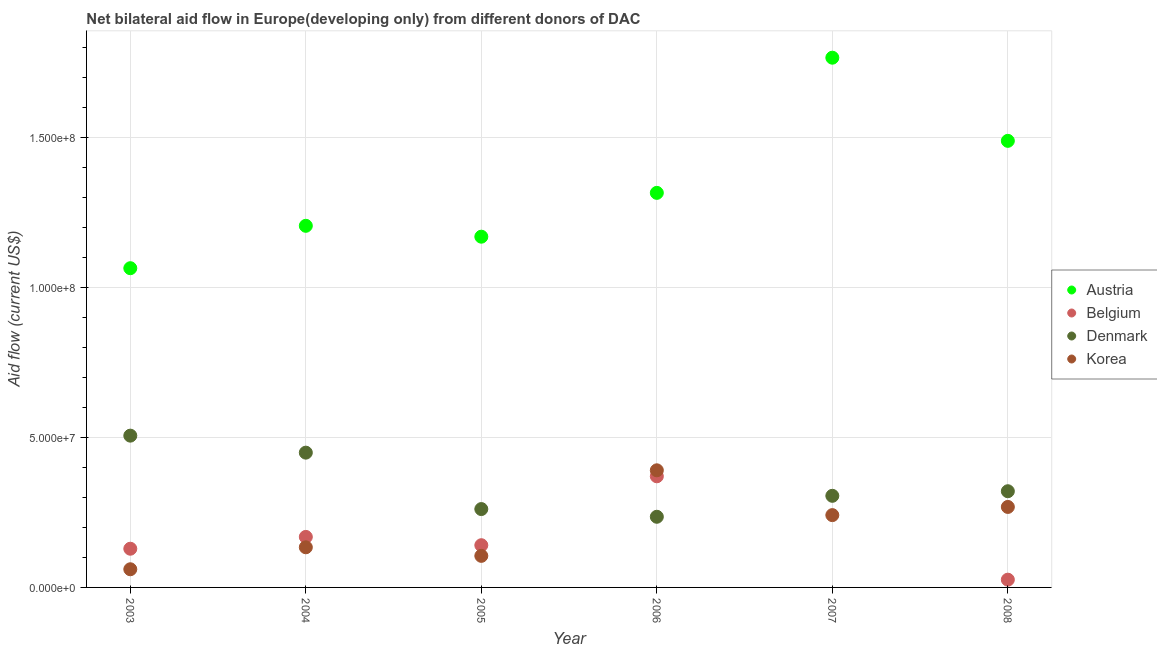How many different coloured dotlines are there?
Your response must be concise. 4. What is the amount of aid given by austria in 2006?
Your response must be concise. 1.32e+08. Across all years, what is the maximum amount of aid given by korea?
Offer a very short reply. 3.91e+07. Across all years, what is the minimum amount of aid given by belgium?
Your response must be concise. 0. In which year was the amount of aid given by korea maximum?
Ensure brevity in your answer.  2006. What is the total amount of aid given by denmark in the graph?
Keep it short and to the point. 2.08e+08. What is the difference between the amount of aid given by austria in 2005 and that in 2008?
Your answer should be compact. -3.20e+07. What is the difference between the amount of aid given by korea in 2003 and the amount of aid given by austria in 2004?
Offer a terse response. -1.15e+08. What is the average amount of aid given by denmark per year?
Ensure brevity in your answer.  3.47e+07. In the year 2003, what is the difference between the amount of aid given by austria and amount of aid given by belgium?
Offer a terse response. 9.36e+07. In how many years, is the amount of aid given by austria greater than 30000000 US$?
Provide a short and direct response. 6. What is the ratio of the amount of aid given by korea in 2003 to that in 2008?
Keep it short and to the point. 0.23. What is the difference between the highest and the second highest amount of aid given by austria?
Your answer should be very brief. 2.77e+07. What is the difference between the highest and the lowest amount of aid given by belgium?
Offer a terse response. 3.71e+07. In how many years, is the amount of aid given by belgium greater than the average amount of aid given by belgium taken over all years?
Your answer should be compact. 3. Is it the case that in every year, the sum of the amount of aid given by austria and amount of aid given by denmark is greater than the sum of amount of aid given by korea and amount of aid given by belgium?
Make the answer very short. Yes. Is the amount of aid given by korea strictly less than the amount of aid given by belgium over the years?
Keep it short and to the point. No. What is the difference between two consecutive major ticks on the Y-axis?
Provide a succinct answer. 5.00e+07. Are the values on the major ticks of Y-axis written in scientific E-notation?
Offer a very short reply. Yes. Does the graph contain any zero values?
Give a very brief answer. Yes. What is the title of the graph?
Provide a short and direct response. Net bilateral aid flow in Europe(developing only) from different donors of DAC. Does "Italy" appear as one of the legend labels in the graph?
Provide a short and direct response. No. What is the label or title of the X-axis?
Offer a terse response. Year. What is the label or title of the Y-axis?
Your answer should be compact. Aid flow (current US$). What is the Aid flow (current US$) of Austria in 2003?
Keep it short and to the point. 1.06e+08. What is the Aid flow (current US$) in Belgium in 2003?
Your answer should be compact. 1.29e+07. What is the Aid flow (current US$) of Denmark in 2003?
Ensure brevity in your answer.  5.06e+07. What is the Aid flow (current US$) of Korea in 2003?
Offer a very short reply. 6.06e+06. What is the Aid flow (current US$) of Austria in 2004?
Provide a succinct answer. 1.21e+08. What is the Aid flow (current US$) in Belgium in 2004?
Offer a very short reply. 1.68e+07. What is the Aid flow (current US$) of Denmark in 2004?
Your response must be concise. 4.50e+07. What is the Aid flow (current US$) in Korea in 2004?
Your answer should be compact. 1.34e+07. What is the Aid flow (current US$) in Austria in 2005?
Make the answer very short. 1.17e+08. What is the Aid flow (current US$) in Belgium in 2005?
Offer a very short reply. 1.41e+07. What is the Aid flow (current US$) in Denmark in 2005?
Offer a terse response. 2.61e+07. What is the Aid flow (current US$) in Korea in 2005?
Give a very brief answer. 1.05e+07. What is the Aid flow (current US$) in Austria in 2006?
Give a very brief answer. 1.32e+08. What is the Aid flow (current US$) in Belgium in 2006?
Provide a succinct answer. 3.71e+07. What is the Aid flow (current US$) in Denmark in 2006?
Provide a succinct answer. 2.36e+07. What is the Aid flow (current US$) of Korea in 2006?
Your response must be concise. 3.91e+07. What is the Aid flow (current US$) of Austria in 2007?
Provide a short and direct response. 1.77e+08. What is the Aid flow (current US$) in Belgium in 2007?
Keep it short and to the point. 0. What is the Aid flow (current US$) in Denmark in 2007?
Provide a succinct answer. 3.06e+07. What is the Aid flow (current US$) of Korea in 2007?
Offer a terse response. 2.41e+07. What is the Aid flow (current US$) of Austria in 2008?
Give a very brief answer. 1.49e+08. What is the Aid flow (current US$) in Belgium in 2008?
Your response must be concise. 2.59e+06. What is the Aid flow (current US$) in Denmark in 2008?
Offer a terse response. 3.21e+07. What is the Aid flow (current US$) in Korea in 2008?
Keep it short and to the point. 2.68e+07. Across all years, what is the maximum Aid flow (current US$) of Austria?
Make the answer very short. 1.77e+08. Across all years, what is the maximum Aid flow (current US$) in Belgium?
Make the answer very short. 3.71e+07. Across all years, what is the maximum Aid flow (current US$) of Denmark?
Your response must be concise. 5.06e+07. Across all years, what is the maximum Aid flow (current US$) in Korea?
Provide a succinct answer. 3.91e+07. Across all years, what is the minimum Aid flow (current US$) in Austria?
Your answer should be compact. 1.06e+08. Across all years, what is the minimum Aid flow (current US$) in Belgium?
Ensure brevity in your answer.  0. Across all years, what is the minimum Aid flow (current US$) in Denmark?
Offer a terse response. 2.36e+07. Across all years, what is the minimum Aid flow (current US$) in Korea?
Your response must be concise. 6.06e+06. What is the total Aid flow (current US$) of Austria in the graph?
Keep it short and to the point. 8.01e+08. What is the total Aid flow (current US$) in Belgium in the graph?
Keep it short and to the point. 8.35e+07. What is the total Aid flow (current US$) in Denmark in the graph?
Make the answer very short. 2.08e+08. What is the total Aid flow (current US$) of Korea in the graph?
Your response must be concise. 1.20e+08. What is the difference between the Aid flow (current US$) of Austria in 2003 and that in 2004?
Offer a very short reply. -1.41e+07. What is the difference between the Aid flow (current US$) of Belgium in 2003 and that in 2004?
Ensure brevity in your answer.  -3.94e+06. What is the difference between the Aid flow (current US$) of Denmark in 2003 and that in 2004?
Your answer should be very brief. 5.67e+06. What is the difference between the Aid flow (current US$) in Korea in 2003 and that in 2004?
Your answer should be compact. -7.33e+06. What is the difference between the Aid flow (current US$) in Austria in 2003 and that in 2005?
Offer a terse response. -1.05e+07. What is the difference between the Aid flow (current US$) of Belgium in 2003 and that in 2005?
Offer a very short reply. -1.17e+06. What is the difference between the Aid flow (current US$) of Denmark in 2003 and that in 2005?
Offer a terse response. 2.45e+07. What is the difference between the Aid flow (current US$) in Korea in 2003 and that in 2005?
Ensure brevity in your answer.  -4.47e+06. What is the difference between the Aid flow (current US$) in Austria in 2003 and that in 2006?
Provide a short and direct response. -2.51e+07. What is the difference between the Aid flow (current US$) in Belgium in 2003 and that in 2006?
Ensure brevity in your answer.  -2.42e+07. What is the difference between the Aid flow (current US$) in Denmark in 2003 and that in 2006?
Ensure brevity in your answer.  2.71e+07. What is the difference between the Aid flow (current US$) of Korea in 2003 and that in 2006?
Offer a very short reply. -3.30e+07. What is the difference between the Aid flow (current US$) in Austria in 2003 and that in 2007?
Keep it short and to the point. -7.02e+07. What is the difference between the Aid flow (current US$) of Denmark in 2003 and that in 2007?
Ensure brevity in your answer.  2.01e+07. What is the difference between the Aid flow (current US$) in Korea in 2003 and that in 2007?
Your answer should be compact. -1.81e+07. What is the difference between the Aid flow (current US$) of Austria in 2003 and that in 2008?
Offer a very short reply. -4.25e+07. What is the difference between the Aid flow (current US$) in Belgium in 2003 and that in 2008?
Provide a short and direct response. 1.03e+07. What is the difference between the Aid flow (current US$) in Denmark in 2003 and that in 2008?
Keep it short and to the point. 1.85e+07. What is the difference between the Aid flow (current US$) of Korea in 2003 and that in 2008?
Provide a short and direct response. -2.08e+07. What is the difference between the Aid flow (current US$) in Austria in 2004 and that in 2005?
Ensure brevity in your answer.  3.63e+06. What is the difference between the Aid flow (current US$) of Belgium in 2004 and that in 2005?
Provide a short and direct response. 2.77e+06. What is the difference between the Aid flow (current US$) in Denmark in 2004 and that in 2005?
Give a very brief answer. 1.88e+07. What is the difference between the Aid flow (current US$) of Korea in 2004 and that in 2005?
Provide a short and direct response. 2.86e+06. What is the difference between the Aid flow (current US$) of Austria in 2004 and that in 2006?
Keep it short and to the point. -1.10e+07. What is the difference between the Aid flow (current US$) in Belgium in 2004 and that in 2006?
Your answer should be compact. -2.02e+07. What is the difference between the Aid flow (current US$) in Denmark in 2004 and that in 2006?
Ensure brevity in your answer.  2.14e+07. What is the difference between the Aid flow (current US$) of Korea in 2004 and that in 2006?
Offer a very short reply. -2.57e+07. What is the difference between the Aid flow (current US$) of Austria in 2004 and that in 2007?
Keep it short and to the point. -5.61e+07. What is the difference between the Aid flow (current US$) in Denmark in 2004 and that in 2007?
Keep it short and to the point. 1.44e+07. What is the difference between the Aid flow (current US$) in Korea in 2004 and that in 2007?
Provide a succinct answer. -1.07e+07. What is the difference between the Aid flow (current US$) of Austria in 2004 and that in 2008?
Provide a short and direct response. -2.83e+07. What is the difference between the Aid flow (current US$) of Belgium in 2004 and that in 2008?
Your response must be concise. 1.43e+07. What is the difference between the Aid flow (current US$) of Denmark in 2004 and that in 2008?
Your answer should be compact. 1.29e+07. What is the difference between the Aid flow (current US$) of Korea in 2004 and that in 2008?
Ensure brevity in your answer.  -1.35e+07. What is the difference between the Aid flow (current US$) in Austria in 2005 and that in 2006?
Your answer should be very brief. -1.46e+07. What is the difference between the Aid flow (current US$) of Belgium in 2005 and that in 2006?
Your answer should be very brief. -2.30e+07. What is the difference between the Aid flow (current US$) in Denmark in 2005 and that in 2006?
Give a very brief answer. 2.57e+06. What is the difference between the Aid flow (current US$) in Korea in 2005 and that in 2006?
Offer a terse response. -2.85e+07. What is the difference between the Aid flow (current US$) in Austria in 2005 and that in 2007?
Give a very brief answer. -5.97e+07. What is the difference between the Aid flow (current US$) of Denmark in 2005 and that in 2007?
Your response must be concise. -4.42e+06. What is the difference between the Aid flow (current US$) of Korea in 2005 and that in 2007?
Ensure brevity in your answer.  -1.36e+07. What is the difference between the Aid flow (current US$) of Austria in 2005 and that in 2008?
Your answer should be very brief. -3.20e+07. What is the difference between the Aid flow (current US$) in Belgium in 2005 and that in 2008?
Your response must be concise. 1.15e+07. What is the difference between the Aid flow (current US$) of Denmark in 2005 and that in 2008?
Provide a succinct answer. -5.95e+06. What is the difference between the Aid flow (current US$) of Korea in 2005 and that in 2008?
Offer a very short reply. -1.63e+07. What is the difference between the Aid flow (current US$) in Austria in 2006 and that in 2007?
Your answer should be very brief. -4.51e+07. What is the difference between the Aid flow (current US$) in Denmark in 2006 and that in 2007?
Your answer should be very brief. -6.99e+06. What is the difference between the Aid flow (current US$) of Korea in 2006 and that in 2007?
Provide a short and direct response. 1.50e+07. What is the difference between the Aid flow (current US$) in Austria in 2006 and that in 2008?
Offer a very short reply. -1.74e+07. What is the difference between the Aid flow (current US$) of Belgium in 2006 and that in 2008?
Offer a terse response. 3.45e+07. What is the difference between the Aid flow (current US$) in Denmark in 2006 and that in 2008?
Provide a succinct answer. -8.52e+06. What is the difference between the Aid flow (current US$) of Korea in 2006 and that in 2008?
Offer a very short reply. 1.22e+07. What is the difference between the Aid flow (current US$) in Austria in 2007 and that in 2008?
Provide a short and direct response. 2.77e+07. What is the difference between the Aid flow (current US$) of Denmark in 2007 and that in 2008?
Make the answer very short. -1.53e+06. What is the difference between the Aid flow (current US$) of Korea in 2007 and that in 2008?
Offer a terse response. -2.73e+06. What is the difference between the Aid flow (current US$) in Austria in 2003 and the Aid flow (current US$) in Belgium in 2004?
Provide a short and direct response. 8.96e+07. What is the difference between the Aid flow (current US$) of Austria in 2003 and the Aid flow (current US$) of Denmark in 2004?
Offer a very short reply. 6.15e+07. What is the difference between the Aid flow (current US$) in Austria in 2003 and the Aid flow (current US$) in Korea in 2004?
Provide a succinct answer. 9.31e+07. What is the difference between the Aid flow (current US$) of Belgium in 2003 and the Aid flow (current US$) of Denmark in 2004?
Offer a very short reply. -3.20e+07. What is the difference between the Aid flow (current US$) in Belgium in 2003 and the Aid flow (current US$) in Korea in 2004?
Your response must be concise. -4.80e+05. What is the difference between the Aid flow (current US$) of Denmark in 2003 and the Aid flow (current US$) of Korea in 2004?
Keep it short and to the point. 3.72e+07. What is the difference between the Aid flow (current US$) of Austria in 2003 and the Aid flow (current US$) of Belgium in 2005?
Offer a terse response. 9.24e+07. What is the difference between the Aid flow (current US$) in Austria in 2003 and the Aid flow (current US$) in Denmark in 2005?
Provide a short and direct response. 8.04e+07. What is the difference between the Aid flow (current US$) in Austria in 2003 and the Aid flow (current US$) in Korea in 2005?
Provide a succinct answer. 9.60e+07. What is the difference between the Aid flow (current US$) of Belgium in 2003 and the Aid flow (current US$) of Denmark in 2005?
Offer a very short reply. -1.32e+07. What is the difference between the Aid flow (current US$) of Belgium in 2003 and the Aid flow (current US$) of Korea in 2005?
Your response must be concise. 2.38e+06. What is the difference between the Aid flow (current US$) in Denmark in 2003 and the Aid flow (current US$) in Korea in 2005?
Ensure brevity in your answer.  4.01e+07. What is the difference between the Aid flow (current US$) of Austria in 2003 and the Aid flow (current US$) of Belgium in 2006?
Offer a terse response. 6.94e+07. What is the difference between the Aid flow (current US$) in Austria in 2003 and the Aid flow (current US$) in Denmark in 2006?
Your answer should be compact. 8.29e+07. What is the difference between the Aid flow (current US$) in Austria in 2003 and the Aid flow (current US$) in Korea in 2006?
Give a very brief answer. 6.74e+07. What is the difference between the Aid flow (current US$) of Belgium in 2003 and the Aid flow (current US$) of Denmark in 2006?
Offer a very short reply. -1.07e+07. What is the difference between the Aid flow (current US$) of Belgium in 2003 and the Aid flow (current US$) of Korea in 2006?
Your response must be concise. -2.62e+07. What is the difference between the Aid flow (current US$) in Denmark in 2003 and the Aid flow (current US$) in Korea in 2006?
Provide a short and direct response. 1.16e+07. What is the difference between the Aid flow (current US$) of Austria in 2003 and the Aid flow (current US$) of Denmark in 2007?
Your answer should be compact. 7.59e+07. What is the difference between the Aid flow (current US$) of Austria in 2003 and the Aid flow (current US$) of Korea in 2007?
Give a very brief answer. 8.24e+07. What is the difference between the Aid flow (current US$) in Belgium in 2003 and the Aid flow (current US$) in Denmark in 2007?
Offer a terse response. -1.76e+07. What is the difference between the Aid flow (current US$) in Belgium in 2003 and the Aid flow (current US$) in Korea in 2007?
Provide a short and direct response. -1.12e+07. What is the difference between the Aid flow (current US$) in Denmark in 2003 and the Aid flow (current US$) in Korea in 2007?
Keep it short and to the point. 2.65e+07. What is the difference between the Aid flow (current US$) in Austria in 2003 and the Aid flow (current US$) in Belgium in 2008?
Give a very brief answer. 1.04e+08. What is the difference between the Aid flow (current US$) in Austria in 2003 and the Aid flow (current US$) in Denmark in 2008?
Offer a very short reply. 7.44e+07. What is the difference between the Aid flow (current US$) in Austria in 2003 and the Aid flow (current US$) in Korea in 2008?
Offer a very short reply. 7.96e+07. What is the difference between the Aid flow (current US$) in Belgium in 2003 and the Aid flow (current US$) in Denmark in 2008?
Your answer should be very brief. -1.92e+07. What is the difference between the Aid flow (current US$) in Belgium in 2003 and the Aid flow (current US$) in Korea in 2008?
Provide a succinct answer. -1.39e+07. What is the difference between the Aid flow (current US$) in Denmark in 2003 and the Aid flow (current US$) in Korea in 2008?
Make the answer very short. 2.38e+07. What is the difference between the Aid flow (current US$) of Austria in 2004 and the Aid flow (current US$) of Belgium in 2005?
Your answer should be very brief. 1.07e+08. What is the difference between the Aid flow (current US$) in Austria in 2004 and the Aid flow (current US$) in Denmark in 2005?
Your answer should be very brief. 9.45e+07. What is the difference between the Aid flow (current US$) of Austria in 2004 and the Aid flow (current US$) of Korea in 2005?
Keep it short and to the point. 1.10e+08. What is the difference between the Aid flow (current US$) in Belgium in 2004 and the Aid flow (current US$) in Denmark in 2005?
Offer a terse response. -9.29e+06. What is the difference between the Aid flow (current US$) of Belgium in 2004 and the Aid flow (current US$) of Korea in 2005?
Make the answer very short. 6.32e+06. What is the difference between the Aid flow (current US$) of Denmark in 2004 and the Aid flow (current US$) of Korea in 2005?
Your answer should be compact. 3.44e+07. What is the difference between the Aid flow (current US$) of Austria in 2004 and the Aid flow (current US$) of Belgium in 2006?
Provide a succinct answer. 8.36e+07. What is the difference between the Aid flow (current US$) of Austria in 2004 and the Aid flow (current US$) of Denmark in 2006?
Keep it short and to the point. 9.71e+07. What is the difference between the Aid flow (current US$) in Austria in 2004 and the Aid flow (current US$) in Korea in 2006?
Ensure brevity in your answer.  8.16e+07. What is the difference between the Aid flow (current US$) in Belgium in 2004 and the Aid flow (current US$) in Denmark in 2006?
Give a very brief answer. -6.72e+06. What is the difference between the Aid flow (current US$) of Belgium in 2004 and the Aid flow (current US$) of Korea in 2006?
Your answer should be compact. -2.22e+07. What is the difference between the Aid flow (current US$) in Denmark in 2004 and the Aid flow (current US$) in Korea in 2006?
Give a very brief answer. 5.89e+06. What is the difference between the Aid flow (current US$) in Austria in 2004 and the Aid flow (current US$) in Denmark in 2007?
Offer a very short reply. 9.01e+07. What is the difference between the Aid flow (current US$) of Austria in 2004 and the Aid flow (current US$) of Korea in 2007?
Offer a very short reply. 9.65e+07. What is the difference between the Aid flow (current US$) in Belgium in 2004 and the Aid flow (current US$) in Denmark in 2007?
Your answer should be very brief. -1.37e+07. What is the difference between the Aid flow (current US$) in Belgium in 2004 and the Aid flow (current US$) in Korea in 2007?
Offer a terse response. -7.27e+06. What is the difference between the Aid flow (current US$) of Denmark in 2004 and the Aid flow (current US$) of Korea in 2007?
Your answer should be very brief. 2.08e+07. What is the difference between the Aid flow (current US$) in Austria in 2004 and the Aid flow (current US$) in Belgium in 2008?
Your answer should be compact. 1.18e+08. What is the difference between the Aid flow (current US$) of Austria in 2004 and the Aid flow (current US$) of Denmark in 2008?
Your answer should be compact. 8.85e+07. What is the difference between the Aid flow (current US$) of Austria in 2004 and the Aid flow (current US$) of Korea in 2008?
Make the answer very short. 9.38e+07. What is the difference between the Aid flow (current US$) of Belgium in 2004 and the Aid flow (current US$) of Denmark in 2008?
Give a very brief answer. -1.52e+07. What is the difference between the Aid flow (current US$) of Belgium in 2004 and the Aid flow (current US$) of Korea in 2008?
Offer a very short reply. -1.00e+07. What is the difference between the Aid flow (current US$) in Denmark in 2004 and the Aid flow (current US$) in Korea in 2008?
Make the answer very short. 1.81e+07. What is the difference between the Aid flow (current US$) in Austria in 2005 and the Aid flow (current US$) in Belgium in 2006?
Your response must be concise. 7.99e+07. What is the difference between the Aid flow (current US$) of Austria in 2005 and the Aid flow (current US$) of Denmark in 2006?
Your answer should be compact. 9.34e+07. What is the difference between the Aid flow (current US$) in Austria in 2005 and the Aid flow (current US$) in Korea in 2006?
Give a very brief answer. 7.79e+07. What is the difference between the Aid flow (current US$) in Belgium in 2005 and the Aid flow (current US$) in Denmark in 2006?
Your answer should be very brief. -9.49e+06. What is the difference between the Aid flow (current US$) in Belgium in 2005 and the Aid flow (current US$) in Korea in 2006?
Keep it short and to the point. -2.50e+07. What is the difference between the Aid flow (current US$) in Denmark in 2005 and the Aid flow (current US$) in Korea in 2006?
Provide a succinct answer. -1.29e+07. What is the difference between the Aid flow (current US$) of Austria in 2005 and the Aid flow (current US$) of Denmark in 2007?
Provide a succinct answer. 8.64e+07. What is the difference between the Aid flow (current US$) in Austria in 2005 and the Aid flow (current US$) in Korea in 2007?
Offer a terse response. 9.29e+07. What is the difference between the Aid flow (current US$) in Belgium in 2005 and the Aid flow (current US$) in Denmark in 2007?
Give a very brief answer. -1.65e+07. What is the difference between the Aid flow (current US$) in Belgium in 2005 and the Aid flow (current US$) in Korea in 2007?
Offer a very short reply. -1.00e+07. What is the difference between the Aid flow (current US$) in Denmark in 2005 and the Aid flow (current US$) in Korea in 2007?
Your response must be concise. 2.02e+06. What is the difference between the Aid flow (current US$) in Austria in 2005 and the Aid flow (current US$) in Belgium in 2008?
Provide a succinct answer. 1.14e+08. What is the difference between the Aid flow (current US$) in Austria in 2005 and the Aid flow (current US$) in Denmark in 2008?
Provide a succinct answer. 8.49e+07. What is the difference between the Aid flow (current US$) of Austria in 2005 and the Aid flow (current US$) of Korea in 2008?
Keep it short and to the point. 9.02e+07. What is the difference between the Aid flow (current US$) in Belgium in 2005 and the Aid flow (current US$) in Denmark in 2008?
Offer a very short reply. -1.80e+07. What is the difference between the Aid flow (current US$) of Belgium in 2005 and the Aid flow (current US$) of Korea in 2008?
Keep it short and to the point. -1.28e+07. What is the difference between the Aid flow (current US$) of Denmark in 2005 and the Aid flow (current US$) of Korea in 2008?
Your response must be concise. -7.10e+05. What is the difference between the Aid flow (current US$) of Austria in 2006 and the Aid flow (current US$) of Denmark in 2007?
Your response must be concise. 1.01e+08. What is the difference between the Aid flow (current US$) in Austria in 2006 and the Aid flow (current US$) in Korea in 2007?
Offer a very short reply. 1.08e+08. What is the difference between the Aid flow (current US$) in Belgium in 2006 and the Aid flow (current US$) in Denmark in 2007?
Offer a very short reply. 6.51e+06. What is the difference between the Aid flow (current US$) of Belgium in 2006 and the Aid flow (current US$) of Korea in 2007?
Provide a succinct answer. 1.30e+07. What is the difference between the Aid flow (current US$) of Denmark in 2006 and the Aid flow (current US$) of Korea in 2007?
Give a very brief answer. -5.50e+05. What is the difference between the Aid flow (current US$) in Austria in 2006 and the Aid flow (current US$) in Belgium in 2008?
Your answer should be very brief. 1.29e+08. What is the difference between the Aid flow (current US$) of Austria in 2006 and the Aid flow (current US$) of Denmark in 2008?
Your answer should be compact. 9.95e+07. What is the difference between the Aid flow (current US$) of Austria in 2006 and the Aid flow (current US$) of Korea in 2008?
Your response must be concise. 1.05e+08. What is the difference between the Aid flow (current US$) of Belgium in 2006 and the Aid flow (current US$) of Denmark in 2008?
Your answer should be very brief. 4.98e+06. What is the difference between the Aid flow (current US$) of Belgium in 2006 and the Aid flow (current US$) of Korea in 2008?
Provide a succinct answer. 1.02e+07. What is the difference between the Aid flow (current US$) of Denmark in 2006 and the Aid flow (current US$) of Korea in 2008?
Provide a succinct answer. -3.28e+06. What is the difference between the Aid flow (current US$) of Austria in 2007 and the Aid flow (current US$) of Belgium in 2008?
Your answer should be very brief. 1.74e+08. What is the difference between the Aid flow (current US$) in Austria in 2007 and the Aid flow (current US$) in Denmark in 2008?
Provide a short and direct response. 1.45e+08. What is the difference between the Aid flow (current US$) of Austria in 2007 and the Aid flow (current US$) of Korea in 2008?
Make the answer very short. 1.50e+08. What is the difference between the Aid flow (current US$) of Denmark in 2007 and the Aid flow (current US$) of Korea in 2008?
Your response must be concise. 3.71e+06. What is the average Aid flow (current US$) in Austria per year?
Offer a very short reply. 1.34e+08. What is the average Aid flow (current US$) of Belgium per year?
Provide a short and direct response. 1.39e+07. What is the average Aid flow (current US$) of Denmark per year?
Your answer should be very brief. 3.47e+07. What is the average Aid flow (current US$) in Korea per year?
Make the answer very short. 2.00e+07. In the year 2003, what is the difference between the Aid flow (current US$) of Austria and Aid flow (current US$) of Belgium?
Give a very brief answer. 9.36e+07. In the year 2003, what is the difference between the Aid flow (current US$) in Austria and Aid flow (current US$) in Denmark?
Ensure brevity in your answer.  5.59e+07. In the year 2003, what is the difference between the Aid flow (current US$) of Austria and Aid flow (current US$) of Korea?
Your answer should be compact. 1.00e+08. In the year 2003, what is the difference between the Aid flow (current US$) of Belgium and Aid flow (current US$) of Denmark?
Provide a succinct answer. -3.77e+07. In the year 2003, what is the difference between the Aid flow (current US$) of Belgium and Aid flow (current US$) of Korea?
Give a very brief answer. 6.85e+06. In the year 2003, what is the difference between the Aid flow (current US$) of Denmark and Aid flow (current US$) of Korea?
Offer a very short reply. 4.46e+07. In the year 2004, what is the difference between the Aid flow (current US$) in Austria and Aid flow (current US$) in Belgium?
Provide a succinct answer. 1.04e+08. In the year 2004, what is the difference between the Aid flow (current US$) in Austria and Aid flow (current US$) in Denmark?
Make the answer very short. 7.57e+07. In the year 2004, what is the difference between the Aid flow (current US$) of Austria and Aid flow (current US$) of Korea?
Ensure brevity in your answer.  1.07e+08. In the year 2004, what is the difference between the Aid flow (current US$) in Belgium and Aid flow (current US$) in Denmark?
Provide a short and direct response. -2.81e+07. In the year 2004, what is the difference between the Aid flow (current US$) of Belgium and Aid flow (current US$) of Korea?
Your answer should be compact. 3.46e+06. In the year 2004, what is the difference between the Aid flow (current US$) of Denmark and Aid flow (current US$) of Korea?
Provide a succinct answer. 3.16e+07. In the year 2005, what is the difference between the Aid flow (current US$) of Austria and Aid flow (current US$) of Belgium?
Provide a short and direct response. 1.03e+08. In the year 2005, what is the difference between the Aid flow (current US$) of Austria and Aid flow (current US$) of Denmark?
Your response must be concise. 9.09e+07. In the year 2005, what is the difference between the Aid flow (current US$) in Austria and Aid flow (current US$) in Korea?
Provide a succinct answer. 1.06e+08. In the year 2005, what is the difference between the Aid flow (current US$) in Belgium and Aid flow (current US$) in Denmark?
Offer a terse response. -1.21e+07. In the year 2005, what is the difference between the Aid flow (current US$) of Belgium and Aid flow (current US$) of Korea?
Offer a very short reply. 3.55e+06. In the year 2005, what is the difference between the Aid flow (current US$) of Denmark and Aid flow (current US$) of Korea?
Provide a succinct answer. 1.56e+07. In the year 2006, what is the difference between the Aid flow (current US$) in Austria and Aid flow (current US$) in Belgium?
Keep it short and to the point. 9.46e+07. In the year 2006, what is the difference between the Aid flow (current US$) in Austria and Aid flow (current US$) in Denmark?
Your answer should be compact. 1.08e+08. In the year 2006, what is the difference between the Aid flow (current US$) in Austria and Aid flow (current US$) in Korea?
Keep it short and to the point. 9.26e+07. In the year 2006, what is the difference between the Aid flow (current US$) in Belgium and Aid flow (current US$) in Denmark?
Give a very brief answer. 1.35e+07. In the year 2006, what is the difference between the Aid flow (current US$) in Belgium and Aid flow (current US$) in Korea?
Ensure brevity in your answer.  -2.00e+06. In the year 2006, what is the difference between the Aid flow (current US$) of Denmark and Aid flow (current US$) of Korea?
Ensure brevity in your answer.  -1.55e+07. In the year 2007, what is the difference between the Aid flow (current US$) of Austria and Aid flow (current US$) of Denmark?
Make the answer very short. 1.46e+08. In the year 2007, what is the difference between the Aid flow (current US$) in Austria and Aid flow (current US$) in Korea?
Provide a succinct answer. 1.53e+08. In the year 2007, what is the difference between the Aid flow (current US$) in Denmark and Aid flow (current US$) in Korea?
Offer a terse response. 6.44e+06. In the year 2008, what is the difference between the Aid flow (current US$) in Austria and Aid flow (current US$) in Belgium?
Provide a succinct answer. 1.46e+08. In the year 2008, what is the difference between the Aid flow (current US$) of Austria and Aid flow (current US$) of Denmark?
Give a very brief answer. 1.17e+08. In the year 2008, what is the difference between the Aid flow (current US$) of Austria and Aid flow (current US$) of Korea?
Offer a terse response. 1.22e+08. In the year 2008, what is the difference between the Aid flow (current US$) of Belgium and Aid flow (current US$) of Denmark?
Keep it short and to the point. -2.95e+07. In the year 2008, what is the difference between the Aid flow (current US$) of Belgium and Aid flow (current US$) of Korea?
Give a very brief answer. -2.43e+07. In the year 2008, what is the difference between the Aid flow (current US$) of Denmark and Aid flow (current US$) of Korea?
Your answer should be compact. 5.24e+06. What is the ratio of the Aid flow (current US$) of Austria in 2003 to that in 2004?
Provide a short and direct response. 0.88. What is the ratio of the Aid flow (current US$) in Belgium in 2003 to that in 2004?
Offer a terse response. 0.77. What is the ratio of the Aid flow (current US$) of Denmark in 2003 to that in 2004?
Your answer should be compact. 1.13. What is the ratio of the Aid flow (current US$) in Korea in 2003 to that in 2004?
Ensure brevity in your answer.  0.45. What is the ratio of the Aid flow (current US$) in Austria in 2003 to that in 2005?
Make the answer very short. 0.91. What is the ratio of the Aid flow (current US$) of Belgium in 2003 to that in 2005?
Your answer should be compact. 0.92. What is the ratio of the Aid flow (current US$) of Denmark in 2003 to that in 2005?
Keep it short and to the point. 1.94. What is the ratio of the Aid flow (current US$) in Korea in 2003 to that in 2005?
Offer a very short reply. 0.58. What is the ratio of the Aid flow (current US$) of Austria in 2003 to that in 2006?
Give a very brief answer. 0.81. What is the ratio of the Aid flow (current US$) of Belgium in 2003 to that in 2006?
Give a very brief answer. 0.35. What is the ratio of the Aid flow (current US$) in Denmark in 2003 to that in 2006?
Offer a terse response. 2.15. What is the ratio of the Aid flow (current US$) of Korea in 2003 to that in 2006?
Provide a succinct answer. 0.16. What is the ratio of the Aid flow (current US$) of Austria in 2003 to that in 2007?
Your answer should be very brief. 0.6. What is the ratio of the Aid flow (current US$) in Denmark in 2003 to that in 2007?
Your answer should be very brief. 1.66. What is the ratio of the Aid flow (current US$) in Korea in 2003 to that in 2007?
Make the answer very short. 0.25. What is the ratio of the Aid flow (current US$) of Austria in 2003 to that in 2008?
Offer a terse response. 0.71. What is the ratio of the Aid flow (current US$) in Belgium in 2003 to that in 2008?
Provide a succinct answer. 4.98. What is the ratio of the Aid flow (current US$) in Denmark in 2003 to that in 2008?
Keep it short and to the point. 1.58. What is the ratio of the Aid flow (current US$) of Korea in 2003 to that in 2008?
Offer a terse response. 0.23. What is the ratio of the Aid flow (current US$) of Austria in 2004 to that in 2005?
Ensure brevity in your answer.  1.03. What is the ratio of the Aid flow (current US$) of Belgium in 2004 to that in 2005?
Provide a short and direct response. 1.2. What is the ratio of the Aid flow (current US$) of Denmark in 2004 to that in 2005?
Provide a succinct answer. 1.72. What is the ratio of the Aid flow (current US$) of Korea in 2004 to that in 2005?
Give a very brief answer. 1.27. What is the ratio of the Aid flow (current US$) of Austria in 2004 to that in 2006?
Your answer should be very brief. 0.92. What is the ratio of the Aid flow (current US$) of Belgium in 2004 to that in 2006?
Provide a short and direct response. 0.45. What is the ratio of the Aid flow (current US$) of Denmark in 2004 to that in 2006?
Offer a terse response. 1.91. What is the ratio of the Aid flow (current US$) in Korea in 2004 to that in 2006?
Provide a short and direct response. 0.34. What is the ratio of the Aid flow (current US$) in Austria in 2004 to that in 2007?
Offer a terse response. 0.68. What is the ratio of the Aid flow (current US$) of Denmark in 2004 to that in 2007?
Ensure brevity in your answer.  1.47. What is the ratio of the Aid flow (current US$) of Korea in 2004 to that in 2007?
Make the answer very short. 0.56. What is the ratio of the Aid flow (current US$) of Austria in 2004 to that in 2008?
Provide a short and direct response. 0.81. What is the ratio of the Aid flow (current US$) in Belgium in 2004 to that in 2008?
Provide a short and direct response. 6.51. What is the ratio of the Aid flow (current US$) in Denmark in 2004 to that in 2008?
Make the answer very short. 1.4. What is the ratio of the Aid flow (current US$) in Korea in 2004 to that in 2008?
Provide a short and direct response. 0.5. What is the ratio of the Aid flow (current US$) in Belgium in 2005 to that in 2006?
Offer a terse response. 0.38. What is the ratio of the Aid flow (current US$) of Denmark in 2005 to that in 2006?
Provide a short and direct response. 1.11. What is the ratio of the Aid flow (current US$) of Korea in 2005 to that in 2006?
Your answer should be compact. 0.27. What is the ratio of the Aid flow (current US$) in Austria in 2005 to that in 2007?
Your response must be concise. 0.66. What is the ratio of the Aid flow (current US$) in Denmark in 2005 to that in 2007?
Provide a succinct answer. 0.86. What is the ratio of the Aid flow (current US$) of Korea in 2005 to that in 2007?
Provide a succinct answer. 0.44. What is the ratio of the Aid flow (current US$) in Austria in 2005 to that in 2008?
Provide a short and direct response. 0.79. What is the ratio of the Aid flow (current US$) in Belgium in 2005 to that in 2008?
Your response must be concise. 5.44. What is the ratio of the Aid flow (current US$) of Denmark in 2005 to that in 2008?
Your answer should be compact. 0.81. What is the ratio of the Aid flow (current US$) in Korea in 2005 to that in 2008?
Provide a short and direct response. 0.39. What is the ratio of the Aid flow (current US$) in Austria in 2006 to that in 2007?
Your response must be concise. 0.74. What is the ratio of the Aid flow (current US$) of Denmark in 2006 to that in 2007?
Provide a succinct answer. 0.77. What is the ratio of the Aid flow (current US$) in Korea in 2006 to that in 2007?
Provide a succinct answer. 1.62. What is the ratio of the Aid flow (current US$) of Austria in 2006 to that in 2008?
Ensure brevity in your answer.  0.88. What is the ratio of the Aid flow (current US$) in Belgium in 2006 to that in 2008?
Provide a short and direct response. 14.31. What is the ratio of the Aid flow (current US$) in Denmark in 2006 to that in 2008?
Provide a short and direct response. 0.73. What is the ratio of the Aid flow (current US$) in Korea in 2006 to that in 2008?
Your response must be concise. 1.46. What is the ratio of the Aid flow (current US$) in Austria in 2007 to that in 2008?
Your answer should be compact. 1.19. What is the ratio of the Aid flow (current US$) of Denmark in 2007 to that in 2008?
Offer a very short reply. 0.95. What is the ratio of the Aid flow (current US$) of Korea in 2007 to that in 2008?
Keep it short and to the point. 0.9. What is the difference between the highest and the second highest Aid flow (current US$) of Austria?
Your answer should be very brief. 2.77e+07. What is the difference between the highest and the second highest Aid flow (current US$) of Belgium?
Your answer should be compact. 2.02e+07. What is the difference between the highest and the second highest Aid flow (current US$) of Denmark?
Make the answer very short. 5.67e+06. What is the difference between the highest and the second highest Aid flow (current US$) of Korea?
Offer a very short reply. 1.22e+07. What is the difference between the highest and the lowest Aid flow (current US$) of Austria?
Keep it short and to the point. 7.02e+07. What is the difference between the highest and the lowest Aid flow (current US$) of Belgium?
Provide a succinct answer. 3.71e+07. What is the difference between the highest and the lowest Aid flow (current US$) of Denmark?
Give a very brief answer. 2.71e+07. What is the difference between the highest and the lowest Aid flow (current US$) in Korea?
Ensure brevity in your answer.  3.30e+07. 